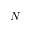Convert formula to latex. <formula><loc_0><loc_0><loc_500><loc_500>N</formula> 